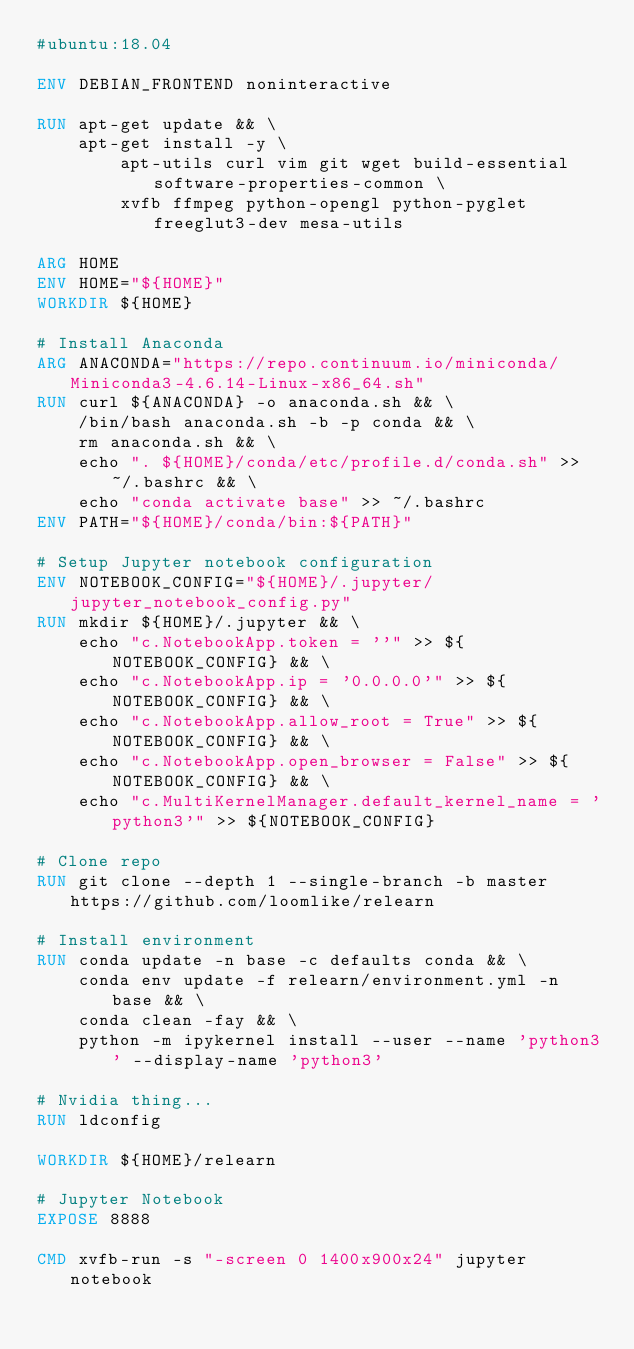<code> <loc_0><loc_0><loc_500><loc_500><_Dockerfile_>#ubuntu:18.04

ENV DEBIAN_FRONTEND noninteractive

RUN apt-get update && \
    apt-get install -y \
        apt-utils curl vim git wget build-essential software-properties-common \
        xvfb ffmpeg python-opengl python-pyglet freeglut3-dev mesa-utils

ARG HOME
ENV HOME="${HOME}"
WORKDIR ${HOME}

# Install Anaconda
ARG ANACONDA="https://repo.continuum.io/miniconda/Miniconda3-4.6.14-Linux-x86_64.sh"
RUN curl ${ANACONDA} -o anaconda.sh && \
    /bin/bash anaconda.sh -b -p conda && \
    rm anaconda.sh && \
    echo ". ${HOME}/conda/etc/profile.d/conda.sh" >> ~/.bashrc && \
    echo "conda activate base" >> ~/.bashrc
ENV PATH="${HOME}/conda/bin:${PATH}"

# Setup Jupyter notebook configuration
ENV NOTEBOOK_CONFIG="${HOME}/.jupyter/jupyter_notebook_config.py"
RUN mkdir ${HOME}/.jupyter && \
    echo "c.NotebookApp.token = ''" >> ${NOTEBOOK_CONFIG} && \
    echo "c.NotebookApp.ip = '0.0.0.0'" >> ${NOTEBOOK_CONFIG} && \
    echo "c.NotebookApp.allow_root = True" >> ${NOTEBOOK_CONFIG} && \
    echo "c.NotebookApp.open_browser = False" >> ${NOTEBOOK_CONFIG} && \
    echo "c.MultiKernelManager.default_kernel_name = 'python3'" >> ${NOTEBOOK_CONFIG}

# Clone repo
RUN git clone --depth 1 --single-branch -b master https://github.com/loomlike/relearn

# Install environment
RUN conda update -n base -c defaults conda && \
    conda env update -f relearn/environment.yml -n base && \
    conda clean -fay && \
    python -m ipykernel install --user --name 'python3' --display-name 'python3'

# Nvidia thing...
RUN ldconfig

WORKDIR ${HOME}/relearn

# Jupyter Notebook
EXPOSE 8888

CMD xvfb-run -s "-screen 0 1400x900x24" jupyter notebook
</code> 